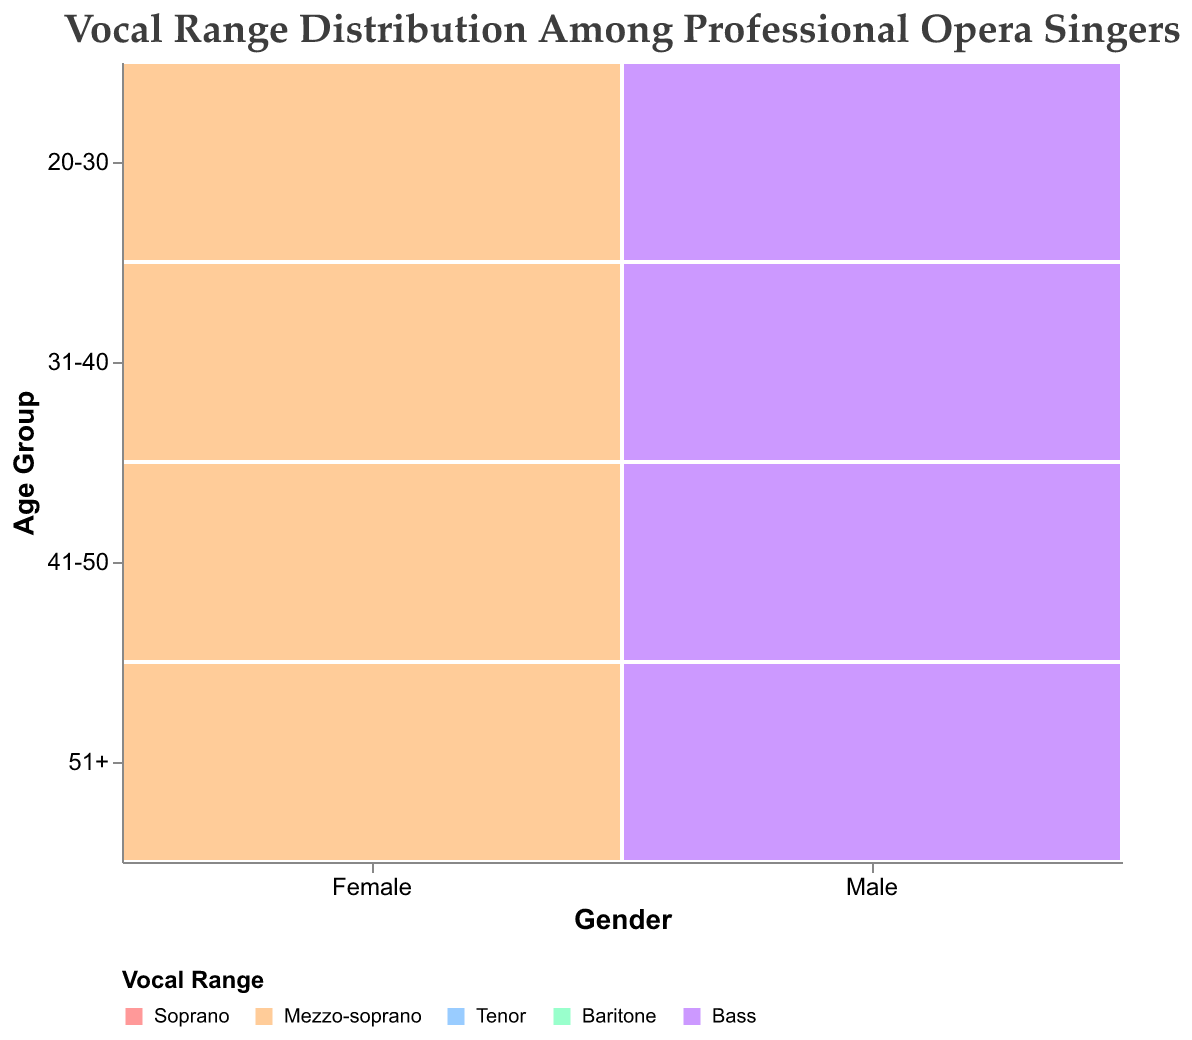What is the total count of Soprano singers aged 31-40? By examining the age group 31-40 in the female category, the number of Soprano singers is represented by a specific section. The count for 31-40 Soprano is 22.
Answer: 22 Which age group has the highest representation of Bass voices among males? The age groups are 20-30, 31-40, 41-50, and 51+. Comparing the counts among males for Bass voices: 20-30 (6), 31-40 (8), 41-50 (10), and 51+ (7), the maximum is in the 41-50 age group.
Answer: 41-50 How many female Mezzo-sopranos are there in the 41-50 age group? Check the visual corresponding to the 41-50 age group for females in the Mezzo-soprano range. The count displayed is 18.
Answer: 18 Which gender and age group combination has the lowest count of vocalists, and what is the vocal range? By inspecting the mosaic plot, identify the segments representing the smallest counts. The 20-30 age group in males with the Bass vocal range has the smallest count, which is 6.
Answer: Male, 20-30, Bass How does the number of Tenors aged 31-40 compare to aged 20-30? Review the counts for Tenors in the specified age groups. For 31-40, the count is 18; for 20-30, it is 14.
Answer: 31-40 has 4 more Tenors than 20-30 What is the sum of all vocalists in the 51+ age group, including both genders? Sum up the counts in the 51+ age group: Female (Soprano 14, Mezzo-soprano 10) and Male (Tenor 12, Baritone 9, Bass 7). Total = 14 + 10 + 12 + 9 + 7 = 52.
Answer: 52 Which vocal range is most common among females in the 20-30 age category? Compare the counts of Soprano (18) and Mezzo-soprano (12). Soprano has a higher count.
Answer: Soprano Is there a greater discrepancy between Soprano and Mezzo-soprano in the age groups 20-30 and 51+ for females? Calculate the differences in both age groups: 20-30 (18 - 12 = 6) and 51+ (14 - 10 = 4). The discrepancy is greater in the 20-30 age group (6 vs. 4).
Answer: Yes, in 20-30 What is the most common vocal range among all male singers, considering all age groups? Add up the counts for each male vocal range across all age groups: Tenor (14+18+16+12 = 60), Baritone (10+14+12+9 = 45), Bass (6+8+10+7 = 31). Tenor has the highest total count.
Answer: Tenor How does the number of male Baritones aged 31-40 compare to that of female Mezzo-sopranos aged 31-40? Evaluate the two groups' counts: Male Baritones (14) and Female Mezzo-sopranos (15).
Answer: Female Mezzo-sopranos have one more 